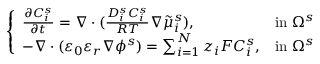Convert formula to latex. <formula><loc_0><loc_0><loc_500><loc_500>\left \{ \begin{array} { l l } { \frac { \partial C _ { i } ^ { s } } { \partial t } = \nabla \cdot ( \frac { D _ { i } ^ { s } C _ { i } ^ { s } } { R T } \nabla \tilde { \mu } _ { i } ^ { s } ) , } & { i n \Omega ^ { s } } \\ { - \nabla \cdot ( \varepsilon _ { 0 } \varepsilon _ { r } \nabla \phi ^ { s } ) = \sum _ { i = 1 } ^ { N } z _ { i } F C _ { i } ^ { s } , } & { i n \Omega ^ { s } } \end{array}</formula> 